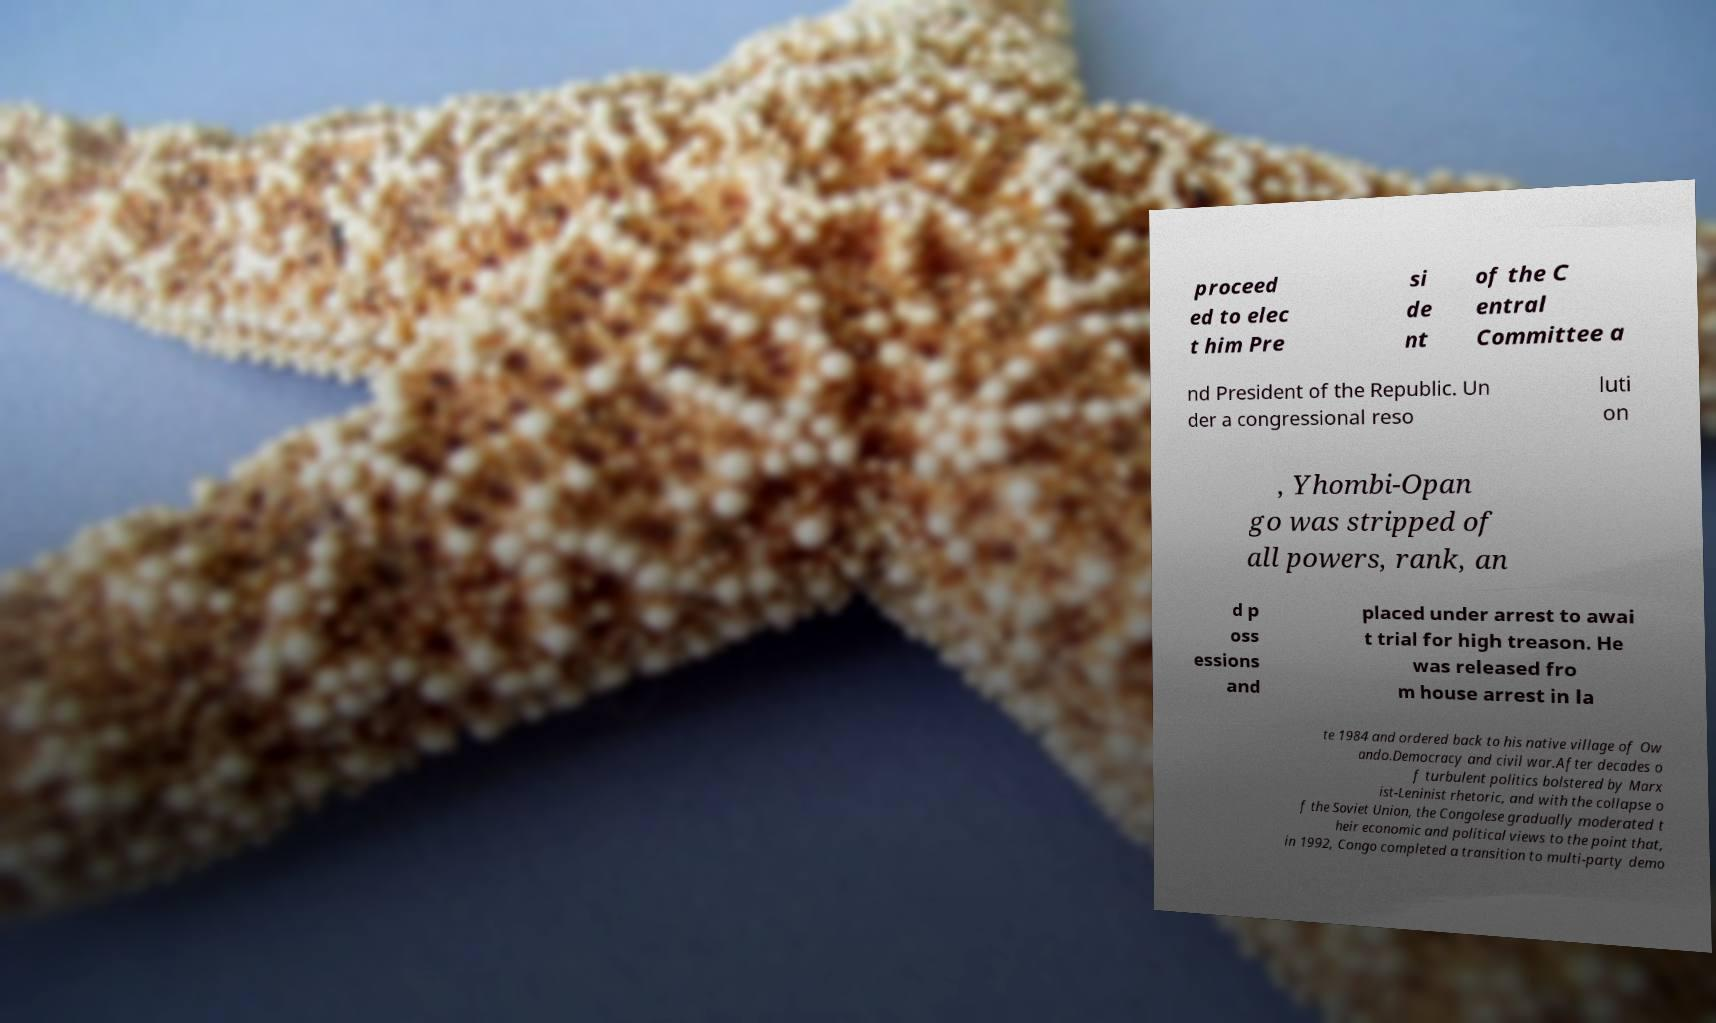Please identify and transcribe the text found in this image. proceed ed to elec t him Pre si de nt of the C entral Committee a nd President of the Republic. Un der a congressional reso luti on , Yhombi-Opan go was stripped of all powers, rank, an d p oss essions and placed under arrest to awai t trial for high treason. He was released fro m house arrest in la te 1984 and ordered back to his native village of Ow ando.Democracy and civil war.After decades o f turbulent politics bolstered by Marx ist-Leninist rhetoric, and with the collapse o f the Soviet Union, the Congolese gradually moderated t heir economic and political views to the point that, in 1992, Congo completed a transition to multi-party demo 